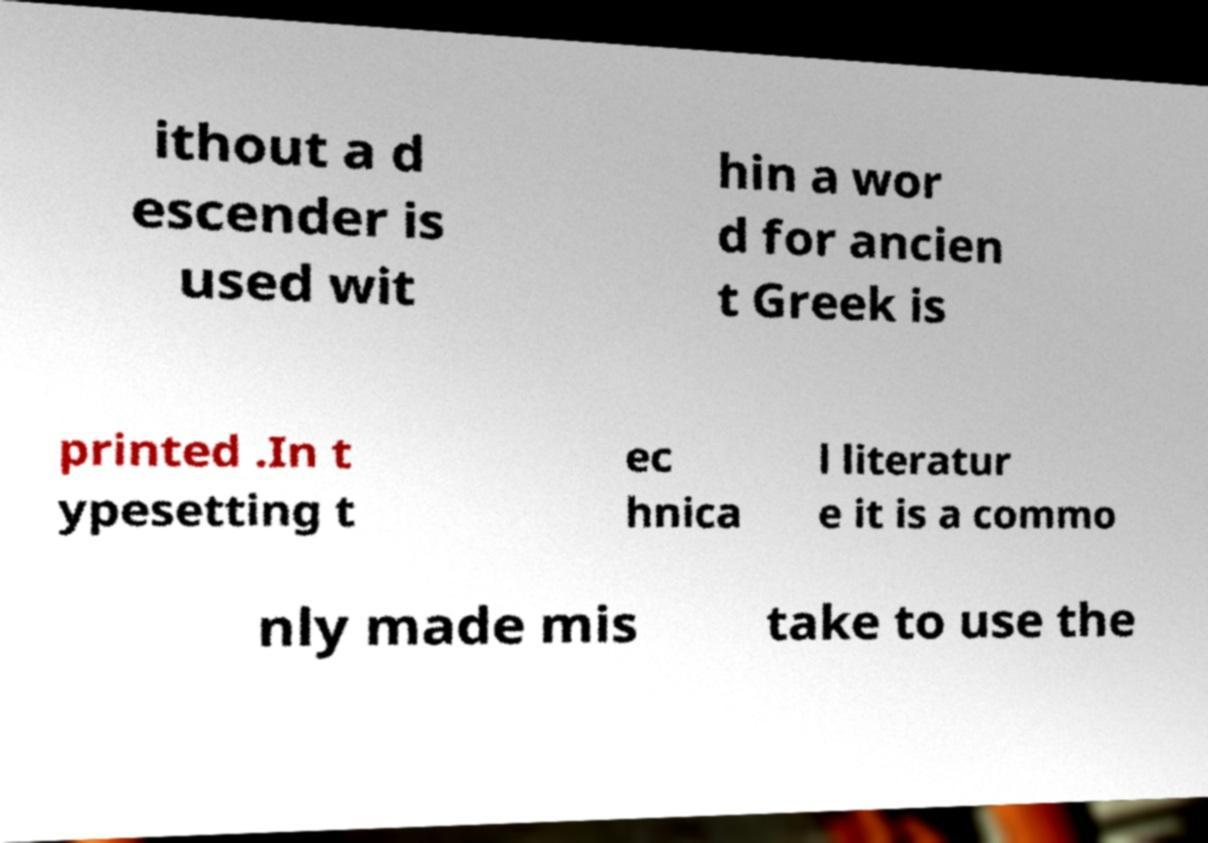I need the written content from this picture converted into text. Can you do that? ithout a d escender is used wit hin a wor d for ancien t Greek is printed .In t ypesetting t ec hnica l literatur e it is a commo nly made mis take to use the 